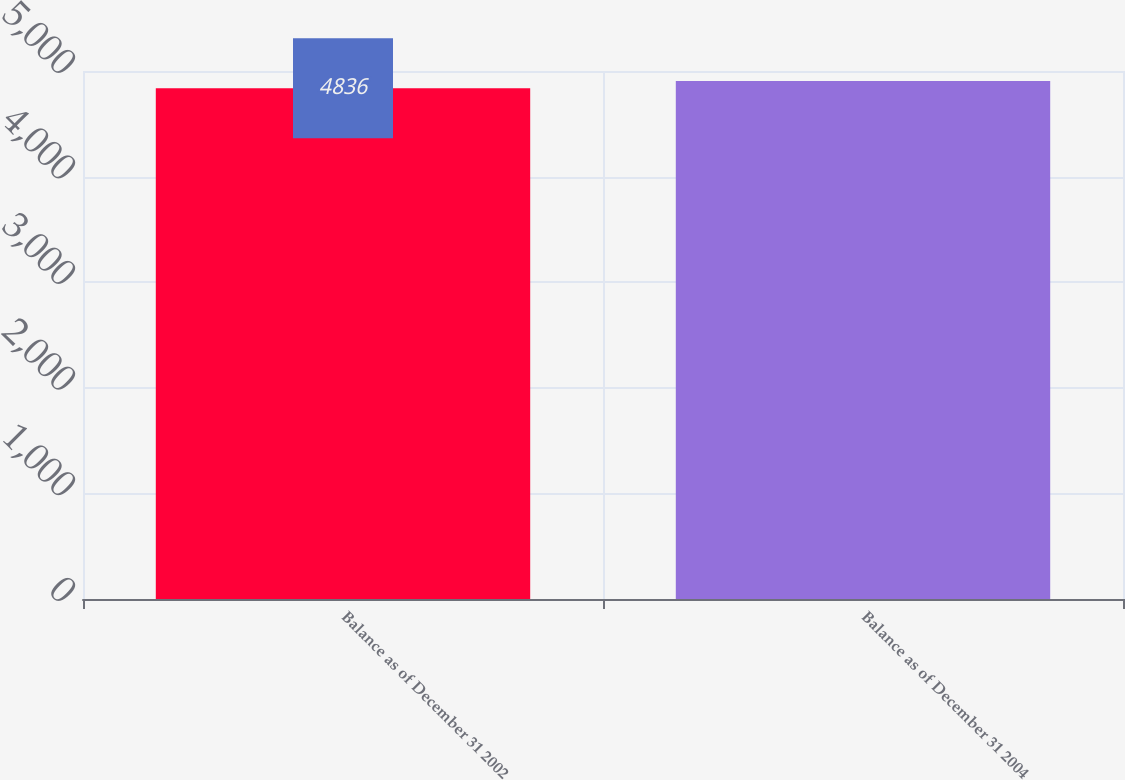Convert chart to OTSL. <chart><loc_0><loc_0><loc_500><loc_500><bar_chart><fcel>Balance as of December 31 2002<fcel>Balance as of December 31 2004<nl><fcel>4836<fcel>4905<nl></chart> 